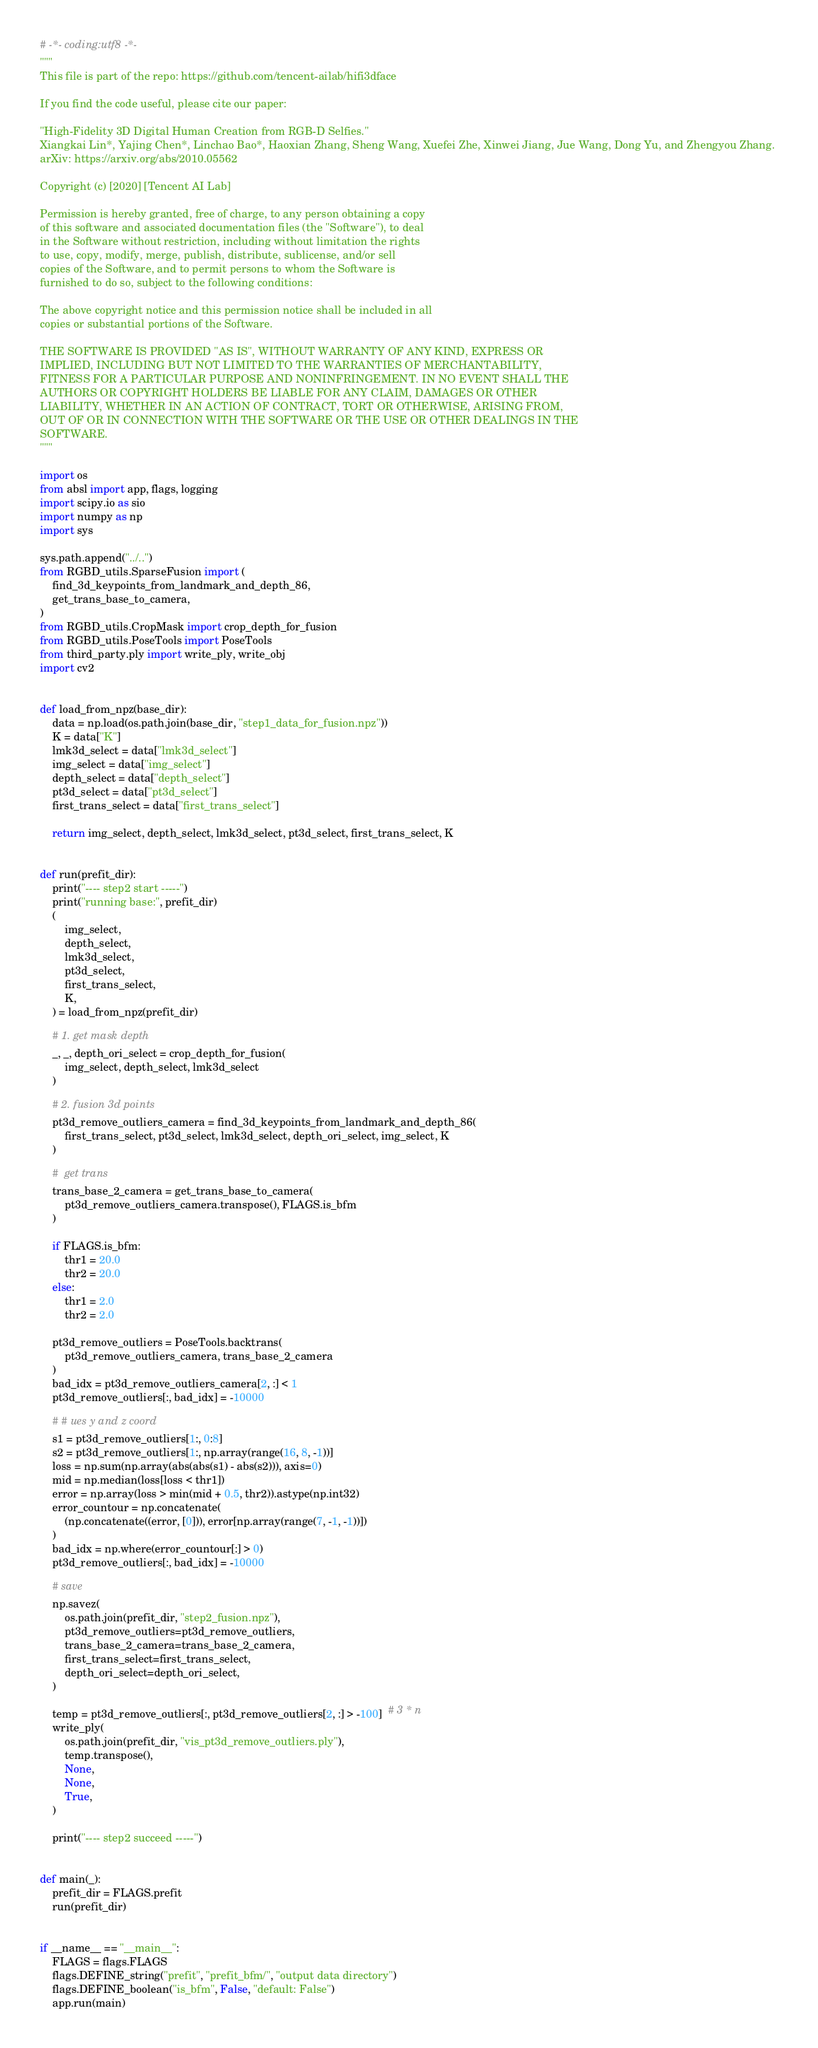<code> <loc_0><loc_0><loc_500><loc_500><_Python_># -*- coding:utf8 -*-
"""
This file is part of the repo: https://github.com/tencent-ailab/hifi3dface

If you find the code useful, please cite our paper: 

"High-Fidelity 3D Digital Human Creation from RGB-D Selfies."
Xiangkai Lin*, Yajing Chen*, Linchao Bao*, Haoxian Zhang, Sheng Wang, Xuefei Zhe, Xinwei Jiang, Jue Wang, Dong Yu, and Zhengyou Zhang. 
arXiv: https://arxiv.org/abs/2010.05562

Copyright (c) [2020] [Tencent AI Lab]

Permission is hereby granted, free of charge, to any person obtaining a copy
of this software and associated documentation files (the "Software"), to deal
in the Software without restriction, including without limitation the rights
to use, copy, modify, merge, publish, distribute, sublicense, and/or sell
copies of the Software, and to permit persons to whom the Software is
furnished to do so, subject to the following conditions:

The above copyright notice and this permission notice shall be included in all
copies or substantial portions of the Software.

THE SOFTWARE IS PROVIDED "AS IS", WITHOUT WARRANTY OF ANY KIND, EXPRESS OR
IMPLIED, INCLUDING BUT NOT LIMITED TO THE WARRANTIES OF MERCHANTABILITY,
FITNESS FOR A PARTICULAR PURPOSE AND NONINFRINGEMENT. IN NO EVENT SHALL THE
AUTHORS OR COPYRIGHT HOLDERS BE LIABLE FOR ANY CLAIM, DAMAGES OR OTHER
LIABILITY, WHETHER IN AN ACTION OF CONTRACT, TORT OR OTHERWISE, ARISING FROM,
OUT OF OR IN CONNECTION WITH THE SOFTWARE OR THE USE OR OTHER DEALINGS IN THE
SOFTWARE.
"""

import os
from absl import app, flags, logging
import scipy.io as sio
import numpy as np
import sys

sys.path.append("../..")
from RGBD_utils.SparseFusion import (
    find_3d_keypoints_from_landmark_and_depth_86,
    get_trans_base_to_camera,
)
from RGBD_utils.CropMask import crop_depth_for_fusion
from RGBD_utils.PoseTools import PoseTools
from third_party.ply import write_ply, write_obj
import cv2


def load_from_npz(base_dir):
    data = np.load(os.path.join(base_dir, "step1_data_for_fusion.npz"))
    K = data["K"]
    lmk3d_select = data["lmk3d_select"]
    img_select = data["img_select"]
    depth_select = data["depth_select"]
    pt3d_select = data["pt3d_select"]
    first_trans_select = data["first_trans_select"]

    return img_select, depth_select, lmk3d_select, pt3d_select, first_trans_select, K


def run(prefit_dir):
    print("---- step2 start -----")
    print("running base:", prefit_dir)
    (
        img_select,
        depth_select,
        lmk3d_select,
        pt3d_select,
        first_trans_select,
        K,
    ) = load_from_npz(prefit_dir)

    # 1. get mask depth
    _, _, depth_ori_select = crop_depth_for_fusion(
        img_select, depth_select, lmk3d_select
    )

    # 2. fusion 3d points
    pt3d_remove_outliers_camera = find_3d_keypoints_from_landmark_and_depth_86(
        first_trans_select, pt3d_select, lmk3d_select, depth_ori_select, img_select, K
    )

    #  get trans
    trans_base_2_camera = get_trans_base_to_camera(
        pt3d_remove_outliers_camera.transpose(), FLAGS.is_bfm
    )

    if FLAGS.is_bfm:
        thr1 = 20.0
        thr2 = 20.0
    else:
        thr1 = 2.0
        thr2 = 2.0

    pt3d_remove_outliers = PoseTools.backtrans(
        pt3d_remove_outliers_camera, trans_base_2_camera
    )
    bad_idx = pt3d_remove_outliers_camera[2, :] < 1
    pt3d_remove_outliers[:, bad_idx] = -10000

    # # ues y and z coord
    s1 = pt3d_remove_outliers[1:, 0:8]
    s2 = pt3d_remove_outliers[1:, np.array(range(16, 8, -1))]
    loss = np.sum(np.array(abs(abs(s1) - abs(s2))), axis=0)
    mid = np.median(loss[loss < thr1])
    error = np.array(loss > min(mid + 0.5, thr2)).astype(np.int32)
    error_countour = np.concatenate(
        (np.concatenate((error, [0])), error[np.array(range(7, -1, -1))])
    )
    bad_idx = np.where(error_countour[:] > 0)
    pt3d_remove_outliers[:, bad_idx] = -10000

    # save
    np.savez(
        os.path.join(prefit_dir, "step2_fusion.npz"),
        pt3d_remove_outliers=pt3d_remove_outliers,
        trans_base_2_camera=trans_base_2_camera,
        first_trans_select=first_trans_select,
        depth_ori_select=depth_ori_select,
    )

    temp = pt3d_remove_outliers[:, pt3d_remove_outliers[2, :] > -100]  # 3 * n
    write_ply(
        os.path.join(prefit_dir, "vis_pt3d_remove_outliers.ply"),
        temp.transpose(),
        None,
        None,
        True,
    )

    print("---- step2 succeed -----")


def main(_):
    prefit_dir = FLAGS.prefit
    run(prefit_dir)


if __name__ == "__main__":
    FLAGS = flags.FLAGS
    flags.DEFINE_string("prefit", "prefit_bfm/", "output data directory")
    flags.DEFINE_boolean("is_bfm", False, "default: False")
    app.run(main)
</code> 